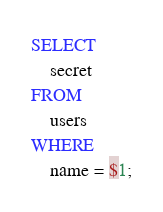Convert code to text. <code><loc_0><loc_0><loc_500><loc_500><_SQL_>SELECT
    secret
FROM
    users
WHERE
    name = $1;

</code> 